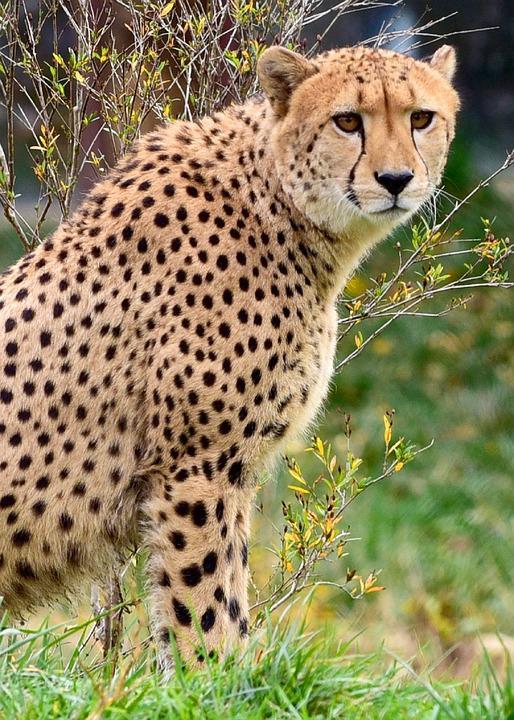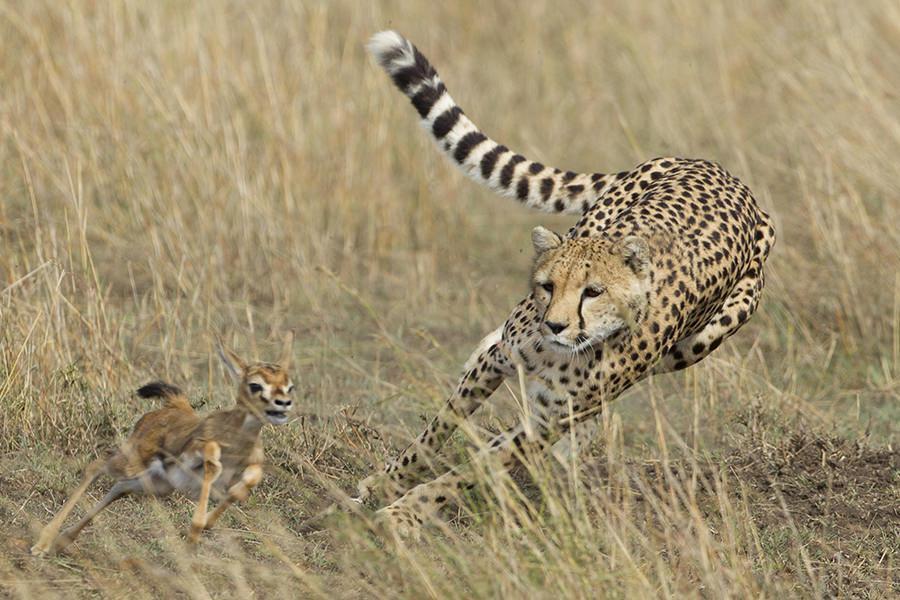The first image is the image on the left, the second image is the image on the right. Examine the images to the left and right. Is the description "There is a single cheetah pursuing a prey in the right image." accurate? Answer yes or no. Yes. The first image is the image on the left, the second image is the image on the right. Analyze the images presented: Is the assertion "In one image, a jaguar is hunting one single prey." valid? Answer yes or no. Yes. 